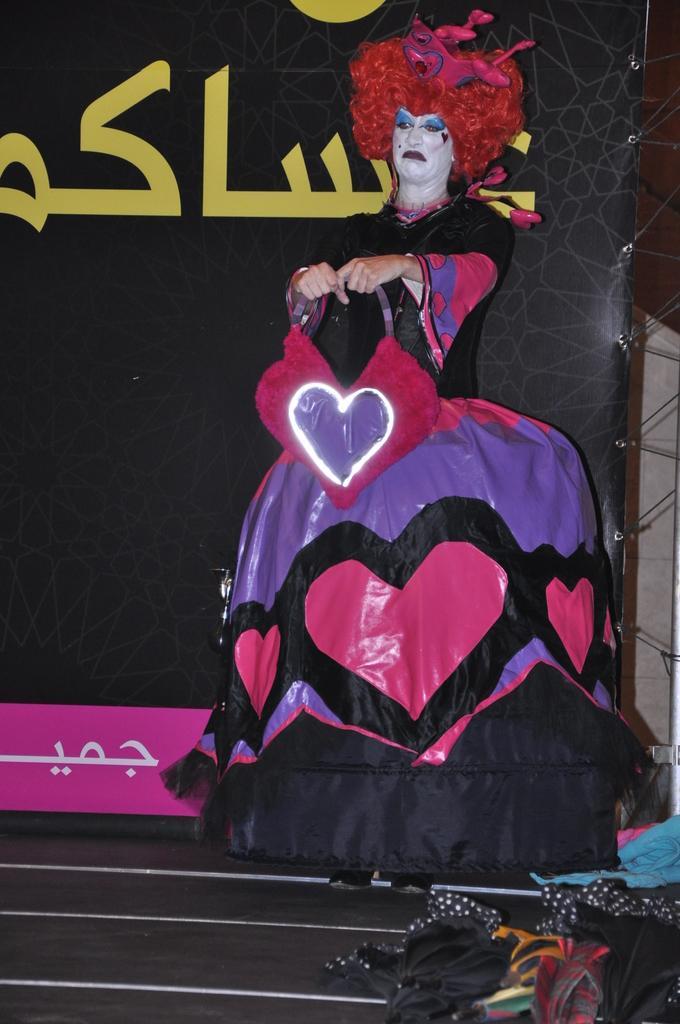Could you give a brief overview of what you see in this image? In this image we can see a person wearing different costume is standing here. Here we can see a few more objects. In the background, we can see the black color banner on which we can see some text. 